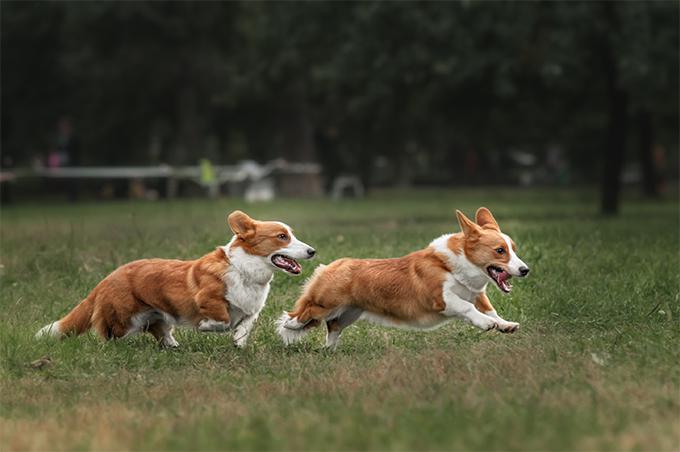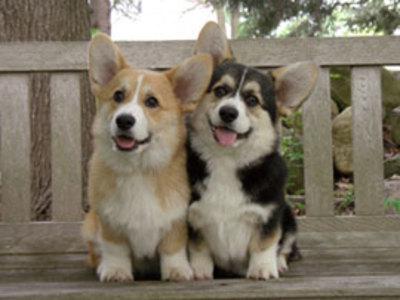The first image is the image on the left, the second image is the image on the right. Analyze the images presented: Is the assertion "Two of the corgis are running with their mouths hanging open, the other two are sitting facing towards the camera." valid? Answer yes or no. Yes. The first image is the image on the left, the second image is the image on the right. Evaluate the accuracy of this statement regarding the images: "An image shows two short-legged dogs running across a grassy area.". Is it true? Answer yes or no. Yes. 